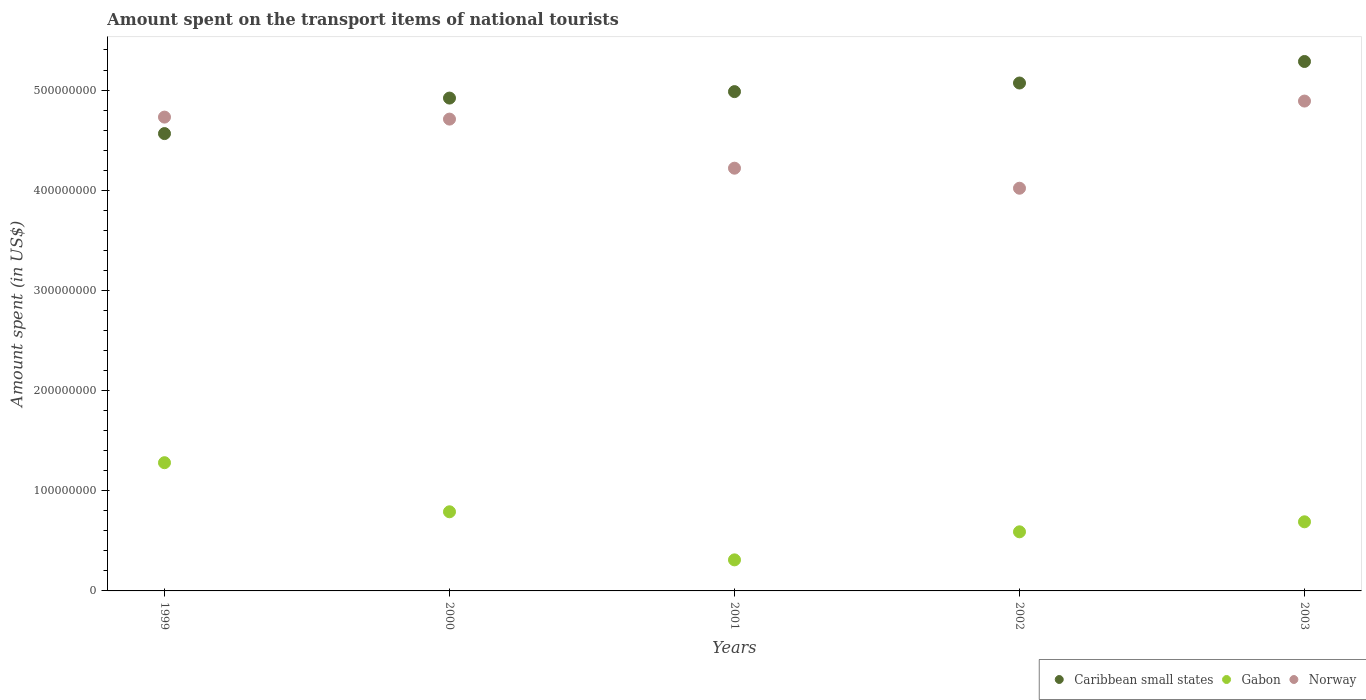How many different coloured dotlines are there?
Offer a terse response. 3. Is the number of dotlines equal to the number of legend labels?
Your answer should be very brief. Yes. What is the amount spent on the transport items of national tourists in Caribbean small states in 2002?
Offer a terse response. 5.07e+08. Across all years, what is the maximum amount spent on the transport items of national tourists in Gabon?
Give a very brief answer. 1.28e+08. Across all years, what is the minimum amount spent on the transport items of national tourists in Norway?
Make the answer very short. 4.02e+08. In which year was the amount spent on the transport items of national tourists in Caribbean small states minimum?
Provide a short and direct response. 1999. What is the total amount spent on the transport items of national tourists in Norway in the graph?
Your response must be concise. 2.26e+09. What is the difference between the amount spent on the transport items of national tourists in Norway in 2000 and that in 2003?
Keep it short and to the point. -1.80e+07. What is the difference between the amount spent on the transport items of national tourists in Norway in 2003 and the amount spent on the transport items of national tourists in Caribbean small states in 1999?
Offer a very short reply. 3.25e+07. What is the average amount spent on the transport items of national tourists in Norway per year?
Your answer should be compact. 4.51e+08. In the year 1999, what is the difference between the amount spent on the transport items of national tourists in Norway and amount spent on the transport items of national tourists in Gabon?
Provide a succinct answer. 3.45e+08. In how many years, is the amount spent on the transport items of national tourists in Caribbean small states greater than 420000000 US$?
Give a very brief answer. 5. What is the ratio of the amount spent on the transport items of national tourists in Gabon in 1999 to that in 2001?
Your answer should be compact. 4.13. Is the amount spent on the transport items of national tourists in Gabon in 2001 less than that in 2002?
Your response must be concise. Yes. What is the difference between the highest and the second highest amount spent on the transport items of national tourists in Norway?
Your response must be concise. 1.60e+07. What is the difference between the highest and the lowest amount spent on the transport items of national tourists in Caribbean small states?
Give a very brief answer. 7.20e+07. Is the sum of the amount spent on the transport items of national tourists in Gabon in 2000 and 2002 greater than the maximum amount spent on the transport items of national tourists in Norway across all years?
Your answer should be very brief. No. Is it the case that in every year, the sum of the amount spent on the transport items of national tourists in Gabon and amount spent on the transport items of national tourists in Caribbean small states  is greater than the amount spent on the transport items of national tourists in Norway?
Give a very brief answer. Yes. Is the amount spent on the transport items of national tourists in Caribbean small states strictly greater than the amount spent on the transport items of national tourists in Gabon over the years?
Give a very brief answer. Yes. Is the amount spent on the transport items of national tourists in Gabon strictly less than the amount spent on the transport items of national tourists in Caribbean small states over the years?
Provide a short and direct response. Yes. How many years are there in the graph?
Provide a short and direct response. 5. Does the graph contain any zero values?
Provide a succinct answer. No. Where does the legend appear in the graph?
Offer a very short reply. Bottom right. How many legend labels are there?
Offer a very short reply. 3. What is the title of the graph?
Your response must be concise. Amount spent on the transport items of national tourists. Does "Arab World" appear as one of the legend labels in the graph?
Keep it short and to the point. No. What is the label or title of the X-axis?
Make the answer very short. Years. What is the label or title of the Y-axis?
Your answer should be compact. Amount spent (in US$). What is the Amount spent (in US$) in Caribbean small states in 1999?
Your answer should be very brief. 4.57e+08. What is the Amount spent (in US$) in Gabon in 1999?
Keep it short and to the point. 1.28e+08. What is the Amount spent (in US$) in Norway in 1999?
Your response must be concise. 4.73e+08. What is the Amount spent (in US$) of Caribbean small states in 2000?
Make the answer very short. 4.92e+08. What is the Amount spent (in US$) in Gabon in 2000?
Provide a short and direct response. 7.90e+07. What is the Amount spent (in US$) in Norway in 2000?
Ensure brevity in your answer.  4.71e+08. What is the Amount spent (in US$) in Caribbean small states in 2001?
Your response must be concise. 4.98e+08. What is the Amount spent (in US$) in Gabon in 2001?
Provide a succinct answer. 3.10e+07. What is the Amount spent (in US$) of Norway in 2001?
Ensure brevity in your answer.  4.22e+08. What is the Amount spent (in US$) of Caribbean small states in 2002?
Keep it short and to the point. 5.07e+08. What is the Amount spent (in US$) in Gabon in 2002?
Your response must be concise. 5.90e+07. What is the Amount spent (in US$) in Norway in 2002?
Give a very brief answer. 4.02e+08. What is the Amount spent (in US$) in Caribbean small states in 2003?
Ensure brevity in your answer.  5.29e+08. What is the Amount spent (in US$) in Gabon in 2003?
Give a very brief answer. 6.90e+07. What is the Amount spent (in US$) in Norway in 2003?
Provide a short and direct response. 4.89e+08. Across all years, what is the maximum Amount spent (in US$) in Caribbean small states?
Offer a very short reply. 5.29e+08. Across all years, what is the maximum Amount spent (in US$) of Gabon?
Keep it short and to the point. 1.28e+08. Across all years, what is the maximum Amount spent (in US$) of Norway?
Provide a succinct answer. 4.89e+08. Across all years, what is the minimum Amount spent (in US$) in Caribbean small states?
Your response must be concise. 4.57e+08. Across all years, what is the minimum Amount spent (in US$) in Gabon?
Make the answer very short. 3.10e+07. Across all years, what is the minimum Amount spent (in US$) of Norway?
Provide a short and direct response. 4.02e+08. What is the total Amount spent (in US$) of Caribbean small states in the graph?
Give a very brief answer. 2.48e+09. What is the total Amount spent (in US$) in Gabon in the graph?
Your response must be concise. 3.66e+08. What is the total Amount spent (in US$) of Norway in the graph?
Provide a succinct answer. 2.26e+09. What is the difference between the Amount spent (in US$) in Caribbean small states in 1999 and that in 2000?
Provide a short and direct response. -3.54e+07. What is the difference between the Amount spent (in US$) in Gabon in 1999 and that in 2000?
Ensure brevity in your answer.  4.90e+07. What is the difference between the Amount spent (in US$) in Norway in 1999 and that in 2000?
Offer a terse response. 2.00e+06. What is the difference between the Amount spent (in US$) of Caribbean small states in 1999 and that in 2001?
Your answer should be compact. -4.19e+07. What is the difference between the Amount spent (in US$) of Gabon in 1999 and that in 2001?
Give a very brief answer. 9.70e+07. What is the difference between the Amount spent (in US$) in Norway in 1999 and that in 2001?
Offer a very short reply. 5.10e+07. What is the difference between the Amount spent (in US$) of Caribbean small states in 1999 and that in 2002?
Offer a very short reply. -5.05e+07. What is the difference between the Amount spent (in US$) of Gabon in 1999 and that in 2002?
Offer a very short reply. 6.90e+07. What is the difference between the Amount spent (in US$) in Norway in 1999 and that in 2002?
Give a very brief answer. 7.10e+07. What is the difference between the Amount spent (in US$) of Caribbean small states in 1999 and that in 2003?
Provide a short and direct response. -7.20e+07. What is the difference between the Amount spent (in US$) in Gabon in 1999 and that in 2003?
Make the answer very short. 5.90e+07. What is the difference between the Amount spent (in US$) in Norway in 1999 and that in 2003?
Ensure brevity in your answer.  -1.60e+07. What is the difference between the Amount spent (in US$) in Caribbean small states in 2000 and that in 2001?
Your answer should be very brief. -6.45e+06. What is the difference between the Amount spent (in US$) of Gabon in 2000 and that in 2001?
Offer a very short reply. 4.80e+07. What is the difference between the Amount spent (in US$) in Norway in 2000 and that in 2001?
Provide a succinct answer. 4.90e+07. What is the difference between the Amount spent (in US$) in Caribbean small states in 2000 and that in 2002?
Your answer should be very brief. -1.50e+07. What is the difference between the Amount spent (in US$) in Gabon in 2000 and that in 2002?
Your answer should be compact. 2.00e+07. What is the difference between the Amount spent (in US$) in Norway in 2000 and that in 2002?
Offer a very short reply. 6.90e+07. What is the difference between the Amount spent (in US$) of Caribbean small states in 2000 and that in 2003?
Ensure brevity in your answer.  -3.65e+07. What is the difference between the Amount spent (in US$) of Norway in 2000 and that in 2003?
Make the answer very short. -1.80e+07. What is the difference between the Amount spent (in US$) in Caribbean small states in 2001 and that in 2002?
Ensure brevity in your answer.  -8.59e+06. What is the difference between the Amount spent (in US$) in Gabon in 2001 and that in 2002?
Provide a short and direct response. -2.80e+07. What is the difference between the Amount spent (in US$) of Norway in 2001 and that in 2002?
Offer a very short reply. 2.00e+07. What is the difference between the Amount spent (in US$) of Caribbean small states in 2001 and that in 2003?
Offer a terse response. -3.01e+07. What is the difference between the Amount spent (in US$) in Gabon in 2001 and that in 2003?
Your answer should be very brief. -3.80e+07. What is the difference between the Amount spent (in US$) in Norway in 2001 and that in 2003?
Offer a terse response. -6.70e+07. What is the difference between the Amount spent (in US$) in Caribbean small states in 2002 and that in 2003?
Provide a short and direct response. -2.15e+07. What is the difference between the Amount spent (in US$) in Gabon in 2002 and that in 2003?
Give a very brief answer. -1.00e+07. What is the difference between the Amount spent (in US$) in Norway in 2002 and that in 2003?
Provide a succinct answer. -8.70e+07. What is the difference between the Amount spent (in US$) in Caribbean small states in 1999 and the Amount spent (in US$) in Gabon in 2000?
Make the answer very short. 3.78e+08. What is the difference between the Amount spent (in US$) of Caribbean small states in 1999 and the Amount spent (in US$) of Norway in 2000?
Offer a terse response. -1.45e+07. What is the difference between the Amount spent (in US$) in Gabon in 1999 and the Amount spent (in US$) in Norway in 2000?
Your answer should be very brief. -3.43e+08. What is the difference between the Amount spent (in US$) in Caribbean small states in 1999 and the Amount spent (in US$) in Gabon in 2001?
Give a very brief answer. 4.26e+08. What is the difference between the Amount spent (in US$) in Caribbean small states in 1999 and the Amount spent (in US$) in Norway in 2001?
Your answer should be very brief. 3.45e+07. What is the difference between the Amount spent (in US$) of Gabon in 1999 and the Amount spent (in US$) of Norway in 2001?
Offer a very short reply. -2.94e+08. What is the difference between the Amount spent (in US$) in Caribbean small states in 1999 and the Amount spent (in US$) in Gabon in 2002?
Provide a succinct answer. 3.98e+08. What is the difference between the Amount spent (in US$) in Caribbean small states in 1999 and the Amount spent (in US$) in Norway in 2002?
Offer a terse response. 5.45e+07. What is the difference between the Amount spent (in US$) of Gabon in 1999 and the Amount spent (in US$) of Norway in 2002?
Offer a very short reply. -2.74e+08. What is the difference between the Amount spent (in US$) in Caribbean small states in 1999 and the Amount spent (in US$) in Gabon in 2003?
Your answer should be compact. 3.88e+08. What is the difference between the Amount spent (in US$) of Caribbean small states in 1999 and the Amount spent (in US$) of Norway in 2003?
Give a very brief answer. -3.25e+07. What is the difference between the Amount spent (in US$) in Gabon in 1999 and the Amount spent (in US$) in Norway in 2003?
Provide a short and direct response. -3.61e+08. What is the difference between the Amount spent (in US$) of Caribbean small states in 2000 and the Amount spent (in US$) of Gabon in 2001?
Ensure brevity in your answer.  4.61e+08. What is the difference between the Amount spent (in US$) of Caribbean small states in 2000 and the Amount spent (in US$) of Norway in 2001?
Keep it short and to the point. 7.00e+07. What is the difference between the Amount spent (in US$) in Gabon in 2000 and the Amount spent (in US$) in Norway in 2001?
Your answer should be compact. -3.43e+08. What is the difference between the Amount spent (in US$) of Caribbean small states in 2000 and the Amount spent (in US$) of Gabon in 2002?
Your response must be concise. 4.33e+08. What is the difference between the Amount spent (in US$) in Caribbean small states in 2000 and the Amount spent (in US$) in Norway in 2002?
Give a very brief answer. 9.00e+07. What is the difference between the Amount spent (in US$) in Gabon in 2000 and the Amount spent (in US$) in Norway in 2002?
Offer a very short reply. -3.23e+08. What is the difference between the Amount spent (in US$) of Caribbean small states in 2000 and the Amount spent (in US$) of Gabon in 2003?
Your answer should be compact. 4.23e+08. What is the difference between the Amount spent (in US$) of Caribbean small states in 2000 and the Amount spent (in US$) of Norway in 2003?
Offer a terse response. 2.99e+06. What is the difference between the Amount spent (in US$) of Gabon in 2000 and the Amount spent (in US$) of Norway in 2003?
Your response must be concise. -4.10e+08. What is the difference between the Amount spent (in US$) of Caribbean small states in 2001 and the Amount spent (in US$) of Gabon in 2002?
Keep it short and to the point. 4.39e+08. What is the difference between the Amount spent (in US$) of Caribbean small states in 2001 and the Amount spent (in US$) of Norway in 2002?
Keep it short and to the point. 9.64e+07. What is the difference between the Amount spent (in US$) of Gabon in 2001 and the Amount spent (in US$) of Norway in 2002?
Offer a terse response. -3.71e+08. What is the difference between the Amount spent (in US$) of Caribbean small states in 2001 and the Amount spent (in US$) of Gabon in 2003?
Your answer should be very brief. 4.29e+08. What is the difference between the Amount spent (in US$) of Caribbean small states in 2001 and the Amount spent (in US$) of Norway in 2003?
Ensure brevity in your answer.  9.43e+06. What is the difference between the Amount spent (in US$) of Gabon in 2001 and the Amount spent (in US$) of Norway in 2003?
Keep it short and to the point. -4.58e+08. What is the difference between the Amount spent (in US$) of Caribbean small states in 2002 and the Amount spent (in US$) of Gabon in 2003?
Keep it short and to the point. 4.38e+08. What is the difference between the Amount spent (in US$) of Caribbean small states in 2002 and the Amount spent (in US$) of Norway in 2003?
Provide a succinct answer. 1.80e+07. What is the difference between the Amount spent (in US$) in Gabon in 2002 and the Amount spent (in US$) in Norway in 2003?
Give a very brief answer. -4.30e+08. What is the average Amount spent (in US$) of Caribbean small states per year?
Your answer should be very brief. 4.96e+08. What is the average Amount spent (in US$) in Gabon per year?
Provide a short and direct response. 7.32e+07. What is the average Amount spent (in US$) of Norway per year?
Your response must be concise. 4.51e+08. In the year 1999, what is the difference between the Amount spent (in US$) of Caribbean small states and Amount spent (in US$) of Gabon?
Give a very brief answer. 3.29e+08. In the year 1999, what is the difference between the Amount spent (in US$) in Caribbean small states and Amount spent (in US$) in Norway?
Provide a short and direct response. -1.65e+07. In the year 1999, what is the difference between the Amount spent (in US$) of Gabon and Amount spent (in US$) of Norway?
Keep it short and to the point. -3.45e+08. In the year 2000, what is the difference between the Amount spent (in US$) in Caribbean small states and Amount spent (in US$) in Gabon?
Your response must be concise. 4.13e+08. In the year 2000, what is the difference between the Amount spent (in US$) in Caribbean small states and Amount spent (in US$) in Norway?
Keep it short and to the point. 2.10e+07. In the year 2000, what is the difference between the Amount spent (in US$) of Gabon and Amount spent (in US$) of Norway?
Ensure brevity in your answer.  -3.92e+08. In the year 2001, what is the difference between the Amount spent (in US$) in Caribbean small states and Amount spent (in US$) in Gabon?
Keep it short and to the point. 4.67e+08. In the year 2001, what is the difference between the Amount spent (in US$) in Caribbean small states and Amount spent (in US$) in Norway?
Provide a succinct answer. 7.64e+07. In the year 2001, what is the difference between the Amount spent (in US$) in Gabon and Amount spent (in US$) in Norway?
Provide a succinct answer. -3.91e+08. In the year 2002, what is the difference between the Amount spent (in US$) in Caribbean small states and Amount spent (in US$) in Gabon?
Keep it short and to the point. 4.48e+08. In the year 2002, what is the difference between the Amount spent (in US$) of Caribbean small states and Amount spent (in US$) of Norway?
Provide a short and direct response. 1.05e+08. In the year 2002, what is the difference between the Amount spent (in US$) of Gabon and Amount spent (in US$) of Norway?
Offer a very short reply. -3.43e+08. In the year 2003, what is the difference between the Amount spent (in US$) in Caribbean small states and Amount spent (in US$) in Gabon?
Give a very brief answer. 4.60e+08. In the year 2003, what is the difference between the Amount spent (in US$) in Caribbean small states and Amount spent (in US$) in Norway?
Your answer should be very brief. 3.95e+07. In the year 2003, what is the difference between the Amount spent (in US$) in Gabon and Amount spent (in US$) in Norway?
Your answer should be very brief. -4.20e+08. What is the ratio of the Amount spent (in US$) in Caribbean small states in 1999 to that in 2000?
Make the answer very short. 0.93. What is the ratio of the Amount spent (in US$) in Gabon in 1999 to that in 2000?
Your answer should be compact. 1.62. What is the ratio of the Amount spent (in US$) of Norway in 1999 to that in 2000?
Keep it short and to the point. 1. What is the ratio of the Amount spent (in US$) of Caribbean small states in 1999 to that in 2001?
Offer a very short reply. 0.92. What is the ratio of the Amount spent (in US$) of Gabon in 1999 to that in 2001?
Provide a succinct answer. 4.13. What is the ratio of the Amount spent (in US$) in Norway in 1999 to that in 2001?
Offer a very short reply. 1.12. What is the ratio of the Amount spent (in US$) of Caribbean small states in 1999 to that in 2002?
Keep it short and to the point. 0.9. What is the ratio of the Amount spent (in US$) in Gabon in 1999 to that in 2002?
Keep it short and to the point. 2.17. What is the ratio of the Amount spent (in US$) of Norway in 1999 to that in 2002?
Give a very brief answer. 1.18. What is the ratio of the Amount spent (in US$) in Caribbean small states in 1999 to that in 2003?
Ensure brevity in your answer.  0.86. What is the ratio of the Amount spent (in US$) in Gabon in 1999 to that in 2003?
Make the answer very short. 1.86. What is the ratio of the Amount spent (in US$) of Norway in 1999 to that in 2003?
Provide a short and direct response. 0.97. What is the ratio of the Amount spent (in US$) in Caribbean small states in 2000 to that in 2001?
Keep it short and to the point. 0.99. What is the ratio of the Amount spent (in US$) of Gabon in 2000 to that in 2001?
Your answer should be compact. 2.55. What is the ratio of the Amount spent (in US$) in Norway in 2000 to that in 2001?
Ensure brevity in your answer.  1.12. What is the ratio of the Amount spent (in US$) in Caribbean small states in 2000 to that in 2002?
Your response must be concise. 0.97. What is the ratio of the Amount spent (in US$) of Gabon in 2000 to that in 2002?
Give a very brief answer. 1.34. What is the ratio of the Amount spent (in US$) of Norway in 2000 to that in 2002?
Offer a very short reply. 1.17. What is the ratio of the Amount spent (in US$) in Caribbean small states in 2000 to that in 2003?
Give a very brief answer. 0.93. What is the ratio of the Amount spent (in US$) of Gabon in 2000 to that in 2003?
Make the answer very short. 1.14. What is the ratio of the Amount spent (in US$) in Norway in 2000 to that in 2003?
Your response must be concise. 0.96. What is the ratio of the Amount spent (in US$) of Caribbean small states in 2001 to that in 2002?
Make the answer very short. 0.98. What is the ratio of the Amount spent (in US$) in Gabon in 2001 to that in 2002?
Ensure brevity in your answer.  0.53. What is the ratio of the Amount spent (in US$) of Norway in 2001 to that in 2002?
Offer a terse response. 1.05. What is the ratio of the Amount spent (in US$) of Caribbean small states in 2001 to that in 2003?
Provide a short and direct response. 0.94. What is the ratio of the Amount spent (in US$) of Gabon in 2001 to that in 2003?
Your answer should be very brief. 0.45. What is the ratio of the Amount spent (in US$) of Norway in 2001 to that in 2003?
Give a very brief answer. 0.86. What is the ratio of the Amount spent (in US$) of Caribbean small states in 2002 to that in 2003?
Ensure brevity in your answer.  0.96. What is the ratio of the Amount spent (in US$) of Gabon in 2002 to that in 2003?
Keep it short and to the point. 0.86. What is the ratio of the Amount spent (in US$) of Norway in 2002 to that in 2003?
Provide a short and direct response. 0.82. What is the difference between the highest and the second highest Amount spent (in US$) of Caribbean small states?
Your answer should be compact. 2.15e+07. What is the difference between the highest and the second highest Amount spent (in US$) of Gabon?
Provide a succinct answer. 4.90e+07. What is the difference between the highest and the second highest Amount spent (in US$) in Norway?
Ensure brevity in your answer.  1.60e+07. What is the difference between the highest and the lowest Amount spent (in US$) of Caribbean small states?
Offer a very short reply. 7.20e+07. What is the difference between the highest and the lowest Amount spent (in US$) of Gabon?
Make the answer very short. 9.70e+07. What is the difference between the highest and the lowest Amount spent (in US$) of Norway?
Provide a short and direct response. 8.70e+07. 